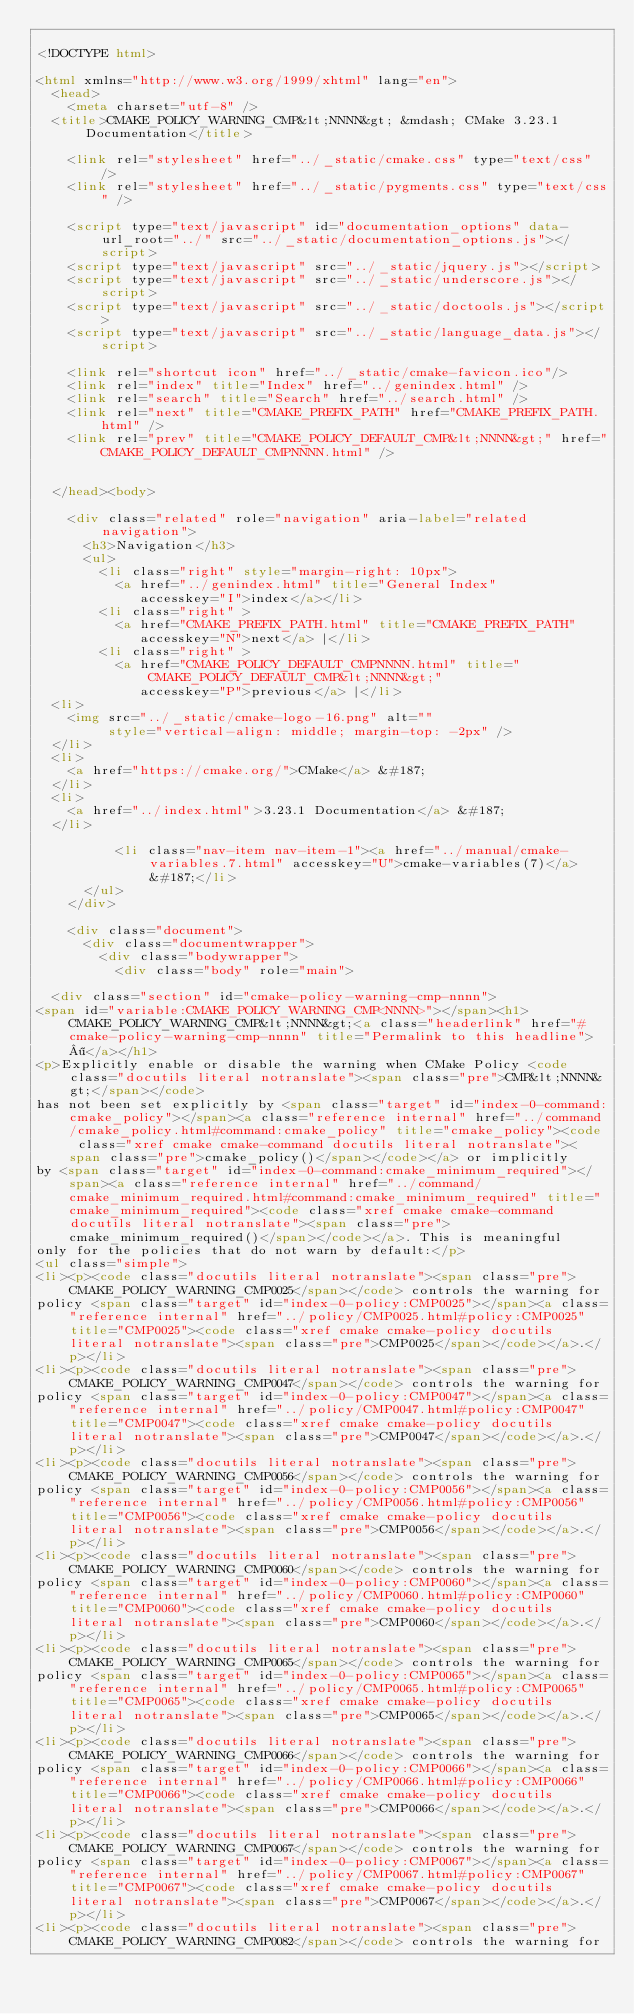Convert code to text. <code><loc_0><loc_0><loc_500><loc_500><_HTML_>
<!DOCTYPE html>

<html xmlns="http://www.w3.org/1999/xhtml" lang="en">
  <head>
    <meta charset="utf-8" />
  <title>CMAKE_POLICY_WARNING_CMP&lt;NNNN&gt; &mdash; CMake 3.23.1 Documentation</title>

    <link rel="stylesheet" href="../_static/cmake.css" type="text/css" />
    <link rel="stylesheet" href="../_static/pygments.css" type="text/css" />
    
    <script type="text/javascript" id="documentation_options" data-url_root="../" src="../_static/documentation_options.js"></script>
    <script type="text/javascript" src="../_static/jquery.js"></script>
    <script type="text/javascript" src="../_static/underscore.js"></script>
    <script type="text/javascript" src="../_static/doctools.js"></script>
    <script type="text/javascript" src="../_static/language_data.js"></script>
    
    <link rel="shortcut icon" href="../_static/cmake-favicon.ico"/>
    <link rel="index" title="Index" href="../genindex.html" />
    <link rel="search" title="Search" href="../search.html" />
    <link rel="next" title="CMAKE_PREFIX_PATH" href="CMAKE_PREFIX_PATH.html" />
    <link rel="prev" title="CMAKE_POLICY_DEFAULT_CMP&lt;NNNN&gt;" href="CMAKE_POLICY_DEFAULT_CMPNNNN.html" />
 

  </head><body>

    <div class="related" role="navigation" aria-label="related navigation">
      <h3>Navigation</h3>
      <ul>
        <li class="right" style="margin-right: 10px">
          <a href="../genindex.html" title="General Index"
             accesskey="I">index</a></li>
        <li class="right" >
          <a href="CMAKE_PREFIX_PATH.html" title="CMAKE_PREFIX_PATH"
             accesskey="N">next</a> |</li>
        <li class="right" >
          <a href="CMAKE_POLICY_DEFAULT_CMPNNNN.html" title="CMAKE_POLICY_DEFAULT_CMP&lt;NNNN&gt;"
             accesskey="P">previous</a> |</li>
  <li>
    <img src="../_static/cmake-logo-16.png" alt=""
         style="vertical-align: middle; margin-top: -2px" />
  </li>
  <li>
    <a href="https://cmake.org/">CMake</a> &#187;
  </li>
  <li>
    <a href="../index.html">3.23.1 Documentation</a> &#187;
  </li>

          <li class="nav-item nav-item-1"><a href="../manual/cmake-variables.7.html" accesskey="U">cmake-variables(7)</a> &#187;</li> 
      </ul>
    </div>  

    <div class="document">
      <div class="documentwrapper">
        <div class="bodywrapper">
          <div class="body" role="main">
            
  <div class="section" id="cmake-policy-warning-cmp-nnnn">
<span id="variable:CMAKE_POLICY_WARNING_CMP<NNNN>"></span><h1>CMAKE_POLICY_WARNING_CMP&lt;NNNN&gt;<a class="headerlink" href="#cmake-policy-warning-cmp-nnnn" title="Permalink to this headline">¶</a></h1>
<p>Explicitly enable or disable the warning when CMake Policy <code class="docutils literal notranslate"><span class="pre">CMP&lt;NNNN&gt;</span></code>
has not been set explicitly by <span class="target" id="index-0-command:cmake_policy"></span><a class="reference internal" href="../command/cmake_policy.html#command:cmake_policy" title="cmake_policy"><code class="xref cmake cmake-command docutils literal notranslate"><span class="pre">cmake_policy()</span></code></a> or implicitly
by <span class="target" id="index-0-command:cmake_minimum_required"></span><a class="reference internal" href="../command/cmake_minimum_required.html#command:cmake_minimum_required" title="cmake_minimum_required"><code class="xref cmake cmake-command docutils literal notranslate"><span class="pre">cmake_minimum_required()</span></code></a>. This is meaningful
only for the policies that do not warn by default:</p>
<ul class="simple">
<li><p><code class="docutils literal notranslate"><span class="pre">CMAKE_POLICY_WARNING_CMP0025</span></code> controls the warning for
policy <span class="target" id="index-0-policy:CMP0025"></span><a class="reference internal" href="../policy/CMP0025.html#policy:CMP0025" title="CMP0025"><code class="xref cmake cmake-policy docutils literal notranslate"><span class="pre">CMP0025</span></code></a>.</p></li>
<li><p><code class="docutils literal notranslate"><span class="pre">CMAKE_POLICY_WARNING_CMP0047</span></code> controls the warning for
policy <span class="target" id="index-0-policy:CMP0047"></span><a class="reference internal" href="../policy/CMP0047.html#policy:CMP0047" title="CMP0047"><code class="xref cmake cmake-policy docutils literal notranslate"><span class="pre">CMP0047</span></code></a>.</p></li>
<li><p><code class="docutils literal notranslate"><span class="pre">CMAKE_POLICY_WARNING_CMP0056</span></code> controls the warning for
policy <span class="target" id="index-0-policy:CMP0056"></span><a class="reference internal" href="../policy/CMP0056.html#policy:CMP0056" title="CMP0056"><code class="xref cmake cmake-policy docutils literal notranslate"><span class="pre">CMP0056</span></code></a>.</p></li>
<li><p><code class="docutils literal notranslate"><span class="pre">CMAKE_POLICY_WARNING_CMP0060</span></code> controls the warning for
policy <span class="target" id="index-0-policy:CMP0060"></span><a class="reference internal" href="../policy/CMP0060.html#policy:CMP0060" title="CMP0060"><code class="xref cmake cmake-policy docutils literal notranslate"><span class="pre">CMP0060</span></code></a>.</p></li>
<li><p><code class="docutils literal notranslate"><span class="pre">CMAKE_POLICY_WARNING_CMP0065</span></code> controls the warning for
policy <span class="target" id="index-0-policy:CMP0065"></span><a class="reference internal" href="../policy/CMP0065.html#policy:CMP0065" title="CMP0065"><code class="xref cmake cmake-policy docutils literal notranslate"><span class="pre">CMP0065</span></code></a>.</p></li>
<li><p><code class="docutils literal notranslate"><span class="pre">CMAKE_POLICY_WARNING_CMP0066</span></code> controls the warning for
policy <span class="target" id="index-0-policy:CMP0066"></span><a class="reference internal" href="../policy/CMP0066.html#policy:CMP0066" title="CMP0066"><code class="xref cmake cmake-policy docutils literal notranslate"><span class="pre">CMP0066</span></code></a>.</p></li>
<li><p><code class="docutils literal notranslate"><span class="pre">CMAKE_POLICY_WARNING_CMP0067</span></code> controls the warning for
policy <span class="target" id="index-0-policy:CMP0067"></span><a class="reference internal" href="../policy/CMP0067.html#policy:CMP0067" title="CMP0067"><code class="xref cmake cmake-policy docutils literal notranslate"><span class="pre">CMP0067</span></code></a>.</p></li>
<li><p><code class="docutils literal notranslate"><span class="pre">CMAKE_POLICY_WARNING_CMP0082</span></code> controls the warning for</code> 